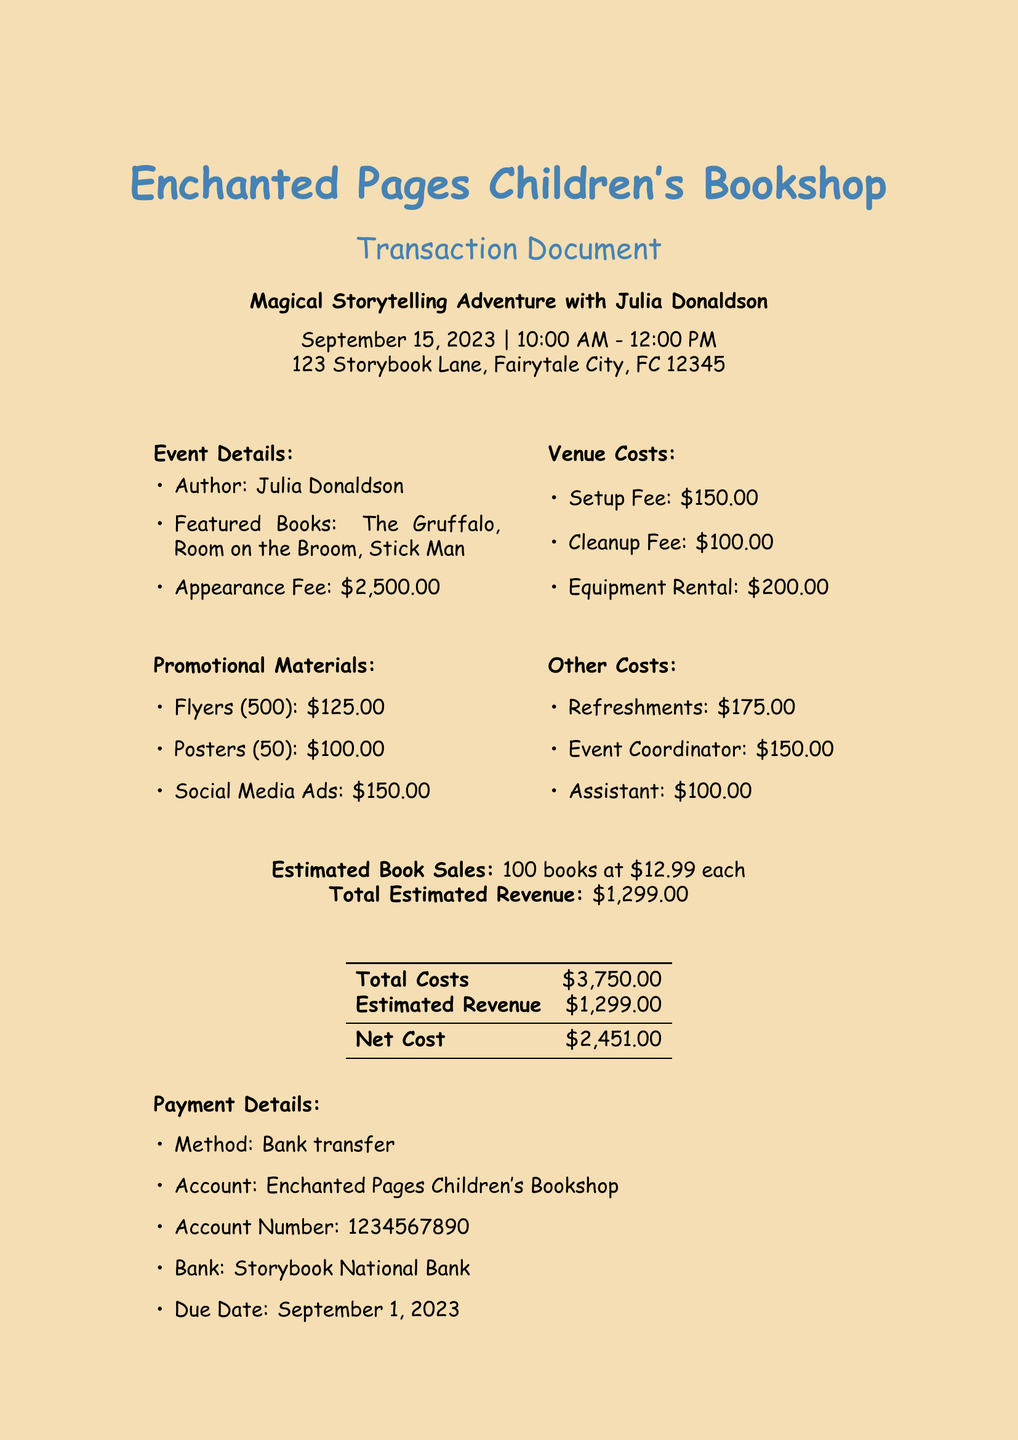What is the author's name? The author's name is explicitly stated in the document.
Answer: Julia Donaldson What is the date of the event? The date of the event is clearly mentioned in the document.
Answer: 2023-09-15 What is the total cost for venue setup, cleanup, and equipment rental? The total cost for venue setup, cleanup, and equipment rental can be calculated as $150.00 + $100.00 + $200.00.
Answer: $450.00 How much will the refreshments cost? The total cost for refreshments is listed in the document.
Answer: $175.00 What is the appearance fee for the author? The appearance fee is specified directly in the document.
Answer: $2500.00 How many flyers were printed? The document states the quantity of flyers printed.
Answer: 500 What is the payment due date? The payment due date is provided in the payment details section.
Answer: 2023-09-01 What is the estimated revenue from book sales? The estimated revenue from book sales is detailed in the document.
Answer: $1299.00 What is the net cost for the event? The net cost is calculated as the total costs minus estimated revenue, as indicated in the document.
Answer: $2451.00 